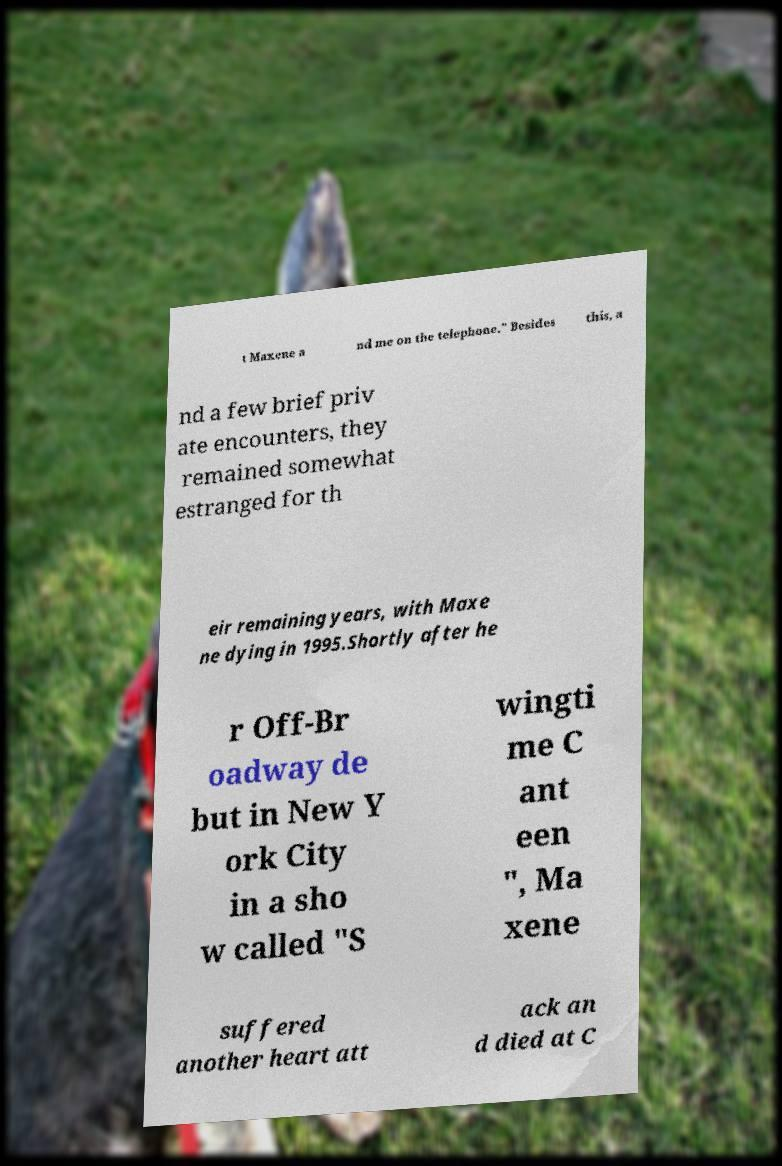Could you assist in decoding the text presented in this image and type it out clearly? t Maxene a nd me on the telephone." Besides this, a nd a few brief priv ate encounters, they remained somewhat estranged for th eir remaining years, with Maxe ne dying in 1995.Shortly after he r Off-Br oadway de but in New Y ork City in a sho w called "S wingti me C ant een ", Ma xene suffered another heart att ack an d died at C 